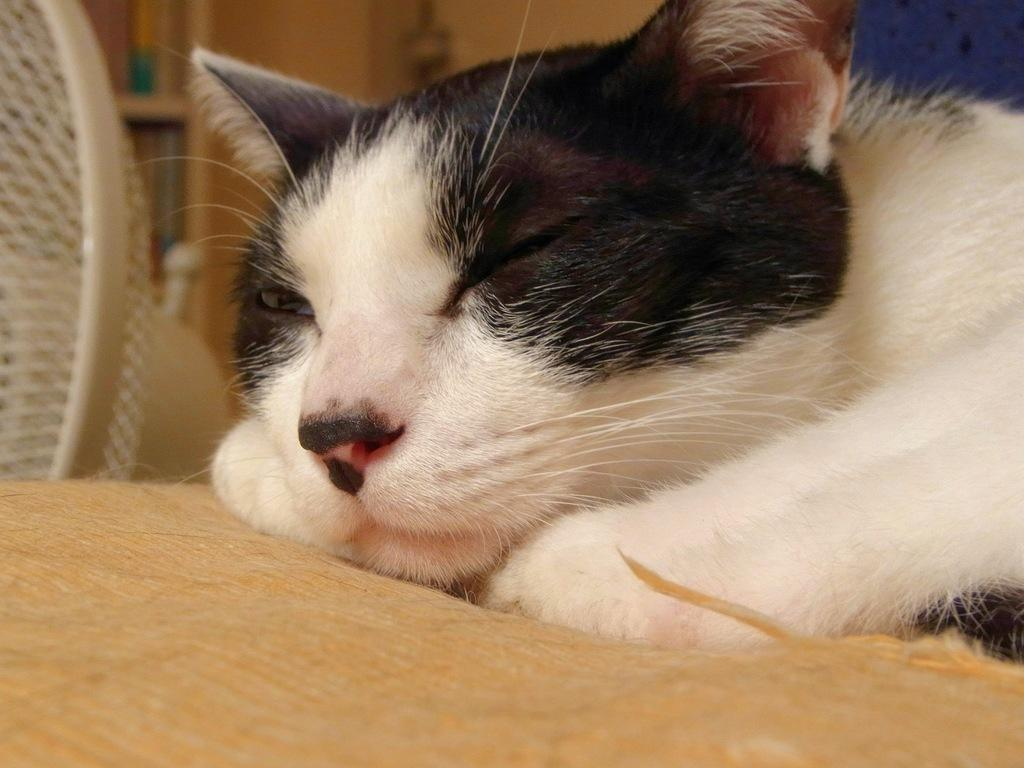What type of animal is in the image? There is a white cat in the image. What is the cat doing in the image? The cat is sleeping. What is the cat resting on in the image? The cat is on a cushion. How would you describe the background of the image? The background of the image is blurred. How many cattle can be seen grazing in the background of the image? There are no cattle present in the image; it features a white cat sleeping on a cushion. What type of nail is being used by the cat in the image? There is no nail being used by the cat in the image; the cat is simply sleeping on a cushion. 